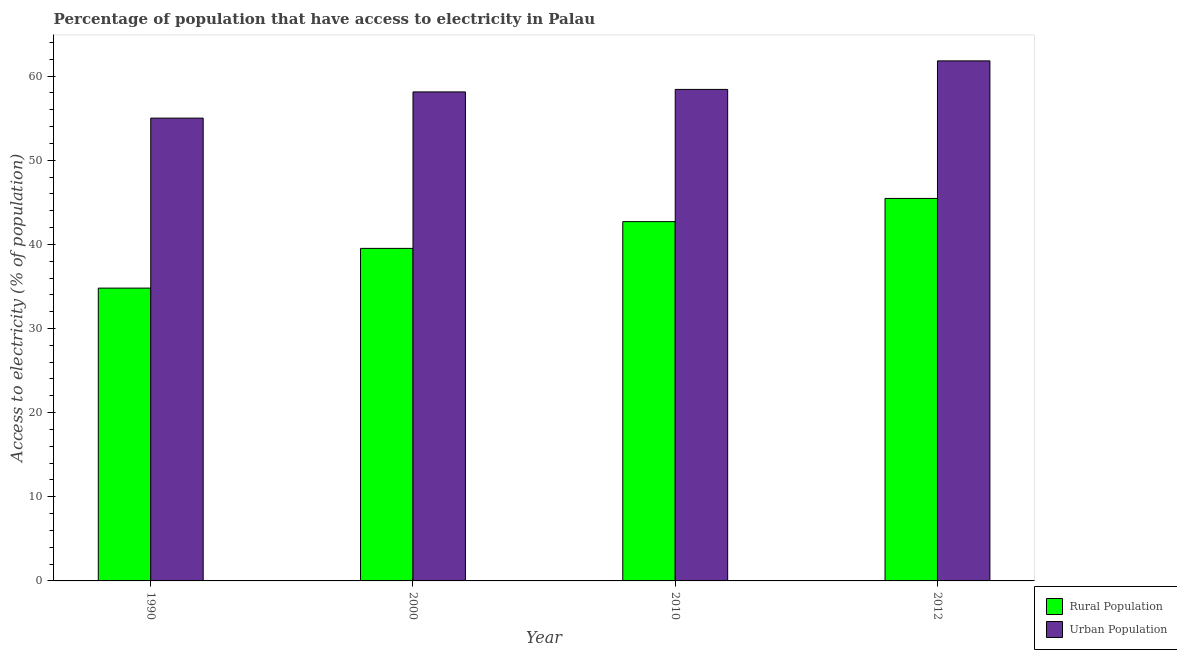How many groups of bars are there?
Provide a short and direct response. 4. Are the number of bars per tick equal to the number of legend labels?
Your answer should be very brief. Yes. Are the number of bars on each tick of the X-axis equal?
Your answer should be very brief. Yes. How many bars are there on the 1st tick from the right?
Make the answer very short. 2. What is the label of the 1st group of bars from the left?
Give a very brief answer. 1990. What is the percentage of urban population having access to electricity in 2012?
Keep it short and to the point. 61.8. Across all years, what is the maximum percentage of rural population having access to electricity?
Your answer should be very brief. 45.45. Across all years, what is the minimum percentage of urban population having access to electricity?
Your answer should be compact. 55. In which year was the percentage of urban population having access to electricity minimum?
Keep it short and to the point. 1990. What is the total percentage of rural population having access to electricity in the graph?
Make the answer very short. 162.47. What is the difference between the percentage of rural population having access to electricity in 1990 and that in 2000?
Ensure brevity in your answer.  -4.72. What is the difference between the percentage of rural population having access to electricity in 1990 and the percentage of urban population having access to electricity in 2000?
Provide a succinct answer. -4.72. What is the average percentage of urban population having access to electricity per year?
Your answer should be compact. 58.33. In the year 2012, what is the difference between the percentage of urban population having access to electricity and percentage of rural population having access to electricity?
Offer a terse response. 0. What is the ratio of the percentage of urban population having access to electricity in 1990 to that in 2010?
Ensure brevity in your answer.  0.94. Is the percentage of rural population having access to electricity in 1990 less than that in 2000?
Provide a succinct answer. Yes. What is the difference between the highest and the second highest percentage of urban population having access to electricity?
Give a very brief answer. 3.39. What is the difference between the highest and the lowest percentage of rural population having access to electricity?
Your response must be concise. 10.66. In how many years, is the percentage of urban population having access to electricity greater than the average percentage of urban population having access to electricity taken over all years?
Make the answer very short. 2. What does the 1st bar from the left in 2000 represents?
Ensure brevity in your answer.  Rural Population. What does the 1st bar from the right in 1990 represents?
Your response must be concise. Urban Population. Are all the bars in the graph horizontal?
Your answer should be compact. No. How many years are there in the graph?
Offer a very short reply. 4. What is the difference between two consecutive major ticks on the Y-axis?
Your answer should be compact. 10. Does the graph contain any zero values?
Offer a very short reply. No. Does the graph contain grids?
Ensure brevity in your answer.  No. What is the title of the graph?
Your answer should be compact. Percentage of population that have access to electricity in Palau. Does "Non-pregnant women" appear as one of the legend labels in the graph?
Make the answer very short. No. What is the label or title of the Y-axis?
Your response must be concise. Access to electricity (% of population). What is the Access to electricity (% of population) in Rural Population in 1990?
Provide a succinct answer. 34.8. What is the Access to electricity (% of population) of Urban Population in 1990?
Keep it short and to the point. 55. What is the Access to electricity (% of population) in Rural Population in 2000?
Give a very brief answer. 39.52. What is the Access to electricity (% of population) in Urban Population in 2000?
Keep it short and to the point. 58.12. What is the Access to electricity (% of population) of Rural Population in 2010?
Ensure brevity in your answer.  42.7. What is the Access to electricity (% of population) of Urban Population in 2010?
Your response must be concise. 58.41. What is the Access to electricity (% of population) in Rural Population in 2012?
Your response must be concise. 45.45. What is the Access to electricity (% of population) in Urban Population in 2012?
Your answer should be compact. 61.8. Across all years, what is the maximum Access to electricity (% of population) of Rural Population?
Offer a very short reply. 45.45. Across all years, what is the maximum Access to electricity (% of population) in Urban Population?
Give a very brief answer. 61.8. Across all years, what is the minimum Access to electricity (% of population) of Rural Population?
Your answer should be very brief. 34.8. Across all years, what is the minimum Access to electricity (% of population) in Urban Population?
Your answer should be compact. 55. What is the total Access to electricity (% of population) in Rural Population in the graph?
Offer a terse response. 162.47. What is the total Access to electricity (% of population) of Urban Population in the graph?
Offer a terse response. 233.34. What is the difference between the Access to electricity (% of population) in Rural Population in 1990 and that in 2000?
Give a very brief answer. -4.72. What is the difference between the Access to electricity (% of population) in Urban Population in 1990 and that in 2000?
Ensure brevity in your answer.  -3.11. What is the difference between the Access to electricity (% of population) of Rural Population in 1990 and that in 2010?
Offer a very short reply. -7.9. What is the difference between the Access to electricity (% of population) in Urban Population in 1990 and that in 2010?
Your answer should be very brief. -3.41. What is the difference between the Access to electricity (% of population) of Rural Population in 1990 and that in 2012?
Provide a succinct answer. -10.66. What is the difference between the Access to electricity (% of population) in Urban Population in 1990 and that in 2012?
Give a very brief answer. -6.8. What is the difference between the Access to electricity (% of population) of Rural Population in 2000 and that in 2010?
Give a very brief answer. -3.18. What is the difference between the Access to electricity (% of population) in Urban Population in 2000 and that in 2010?
Offer a very short reply. -0.3. What is the difference between the Access to electricity (% of population) in Rural Population in 2000 and that in 2012?
Your response must be concise. -5.93. What is the difference between the Access to electricity (% of population) in Urban Population in 2000 and that in 2012?
Offer a terse response. -3.69. What is the difference between the Access to electricity (% of population) in Rural Population in 2010 and that in 2012?
Ensure brevity in your answer.  -2.75. What is the difference between the Access to electricity (% of population) in Urban Population in 2010 and that in 2012?
Your answer should be very brief. -3.39. What is the difference between the Access to electricity (% of population) in Rural Population in 1990 and the Access to electricity (% of population) in Urban Population in 2000?
Your answer should be very brief. -23.32. What is the difference between the Access to electricity (% of population) in Rural Population in 1990 and the Access to electricity (% of population) in Urban Population in 2010?
Your response must be concise. -23.62. What is the difference between the Access to electricity (% of population) in Rural Population in 1990 and the Access to electricity (% of population) in Urban Population in 2012?
Provide a short and direct response. -27.01. What is the difference between the Access to electricity (% of population) in Rural Population in 2000 and the Access to electricity (% of population) in Urban Population in 2010?
Make the answer very short. -18.89. What is the difference between the Access to electricity (% of population) of Rural Population in 2000 and the Access to electricity (% of population) of Urban Population in 2012?
Make the answer very short. -22.28. What is the difference between the Access to electricity (% of population) of Rural Population in 2010 and the Access to electricity (% of population) of Urban Population in 2012?
Give a very brief answer. -19.1. What is the average Access to electricity (% of population) in Rural Population per year?
Your answer should be very brief. 40.62. What is the average Access to electricity (% of population) of Urban Population per year?
Make the answer very short. 58.33. In the year 1990, what is the difference between the Access to electricity (% of population) of Rural Population and Access to electricity (% of population) of Urban Population?
Your response must be concise. -20.2. In the year 2000, what is the difference between the Access to electricity (% of population) of Rural Population and Access to electricity (% of population) of Urban Population?
Give a very brief answer. -18.59. In the year 2010, what is the difference between the Access to electricity (% of population) in Rural Population and Access to electricity (% of population) in Urban Population?
Your answer should be very brief. -15.71. In the year 2012, what is the difference between the Access to electricity (% of population) of Rural Population and Access to electricity (% of population) of Urban Population?
Give a very brief answer. -16.35. What is the ratio of the Access to electricity (% of population) of Rural Population in 1990 to that in 2000?
Make the answer very short. 0.88. What is the ratio of the Access to electricity (% of population) of Urban Population in 1990 to that in 2000?
Make the answer very short. 0.95. What is the ratio of the Access to electricity (% of population) in Rural Population in 1990 to that in 2010?
Your answer should be compact. 0.81. What is the ratio of the Access to electricity (% of population) in Urban Population in 1990 to that in 2010?
Keep it short and to the point. 0.94. What is the ratio of the Access to electricity (% of population) of Rural Population in 1990 to that in 2012?
Keep it short and to the point. 0.77. What is the ratio of the Access to electricity (% of population) of Urban Population in 1990 to that in 2012?
Your answer should be very brief. 0.89. What is the ratio of the Access to electricity (% of population) in Rural Population in 2000 to that in 2010?
Offer a very short reply. 0.93. What is the ratio of the Access to electricity (% of population) in Rural Population in 2000 to that in 2012?
Provide a succinct answer. 0.87. What is the ratio of the Access to electricity (% of population) of Urban Population in 2000 to that in 2012?
Provide a short and direct response. 0.94. What is the ratio of the Access to electricity (% of population) in Rural Population in 2010 to that in 2012?
Ensure brevity in your answer.  0.94. What is the ratio of the Access to electricity (% of population) of Urban Population in 2010 to that in 2012?
Provide a succinct answer. 0.95. What is the difference between the highest and the second highest Access to electricity (% of population) in Rural Population?
Ensure brevity in your answer.  2.75. What is the difference between the highest and the second highest Access to electricity (% of population) of Urban Population?
Provide a succinct answer. 3.39. What is the difference between the highest and the lowest Access to electricity (% of population) of Rural Population?
Your answer should be compact. 10.66. What is the difference between the highest and the lowest Access to electricity (% of population) in Urban Population?
Provide a succinct answer. 6.8. 